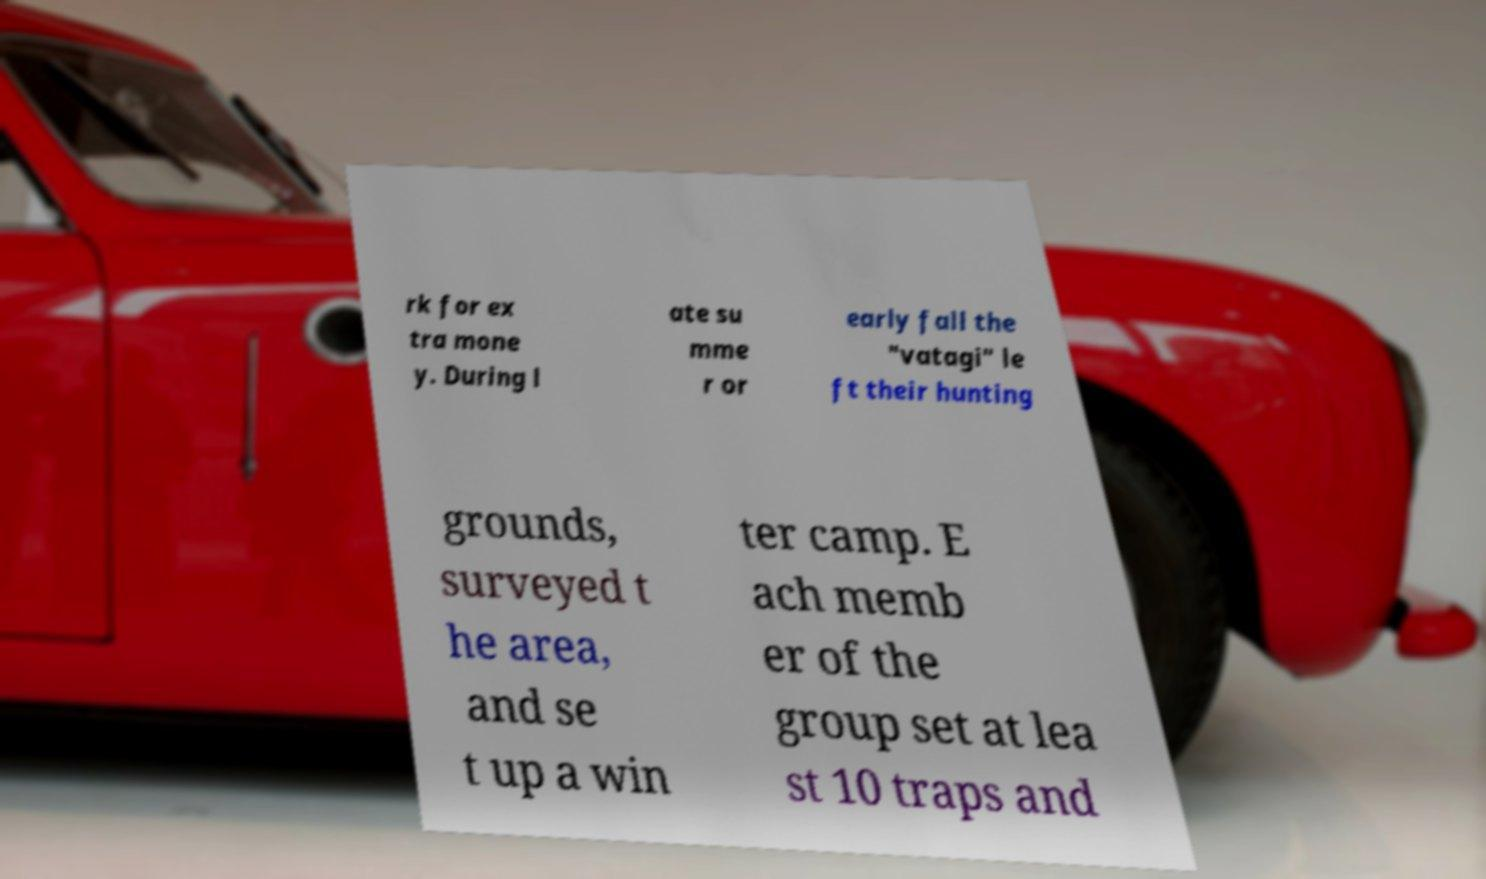What messages or text are displayed in this image? I need them in a readable, typed format. rk for ex tra mone y. During l ate su mme r or early fall the "vatagi" le ft their hunting grounds, surveyed t he area, and se t up a win ter camp. E ach memb er of the group set at lea st 10 traps and 